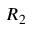Convert formula to latex. <formula><loc_0><loc_0><loc_500><loc_500>R _ { 2 }</formula> 